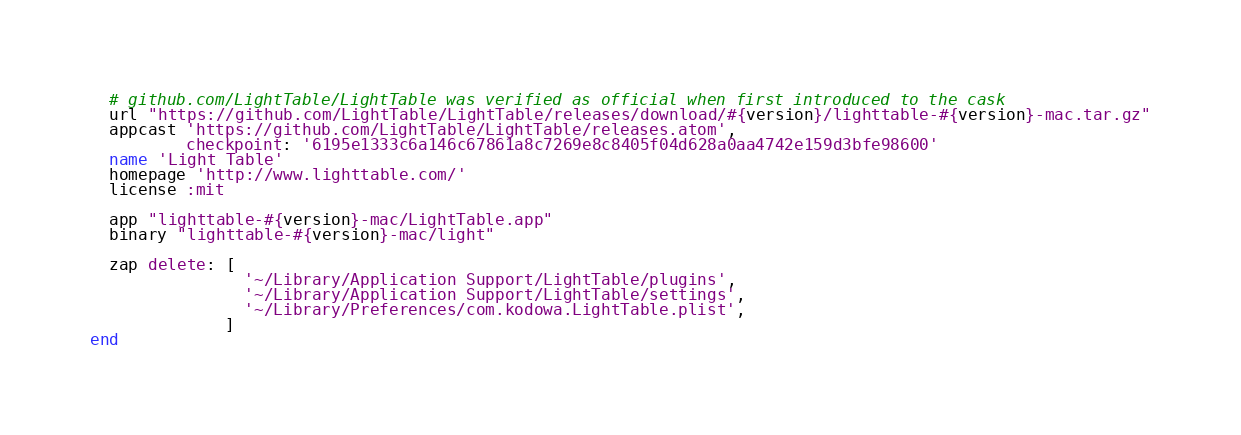Convert code to text. <code><loc_0><loc_0><loc_500><loc_500><_Ruby_>
  # github.com/LightTable/LightTable was verified as official when first introduced to the cask
  url "https://github.com/LightTable/LightTable/releases/download/#{version}/lighttable-#{version}-mac.tar.gz"
  appcast 'https://github.com/LightTable/LightTable/releases.atom',
          checkpoint: '6195e1333c6a146c67861a8c7269e8c8405f04d628a0aa4742e159d3bfe98600'
  name 'Light Table'
  homepage 'http://www.lighttable.com/'
  license :mit

  app "lighttable-#{version}-mac/LightTable.app"
  binary "lighttable-#{version}-mac/light"

  zap delete: [
                '~/Library/Application Support/LightTable/plugins',
                '~/Library/Application Support/LightTable/settings',
                '~/Library/Preferences/com.kodowa.LightTable.plist',
              ]
end
</code> 